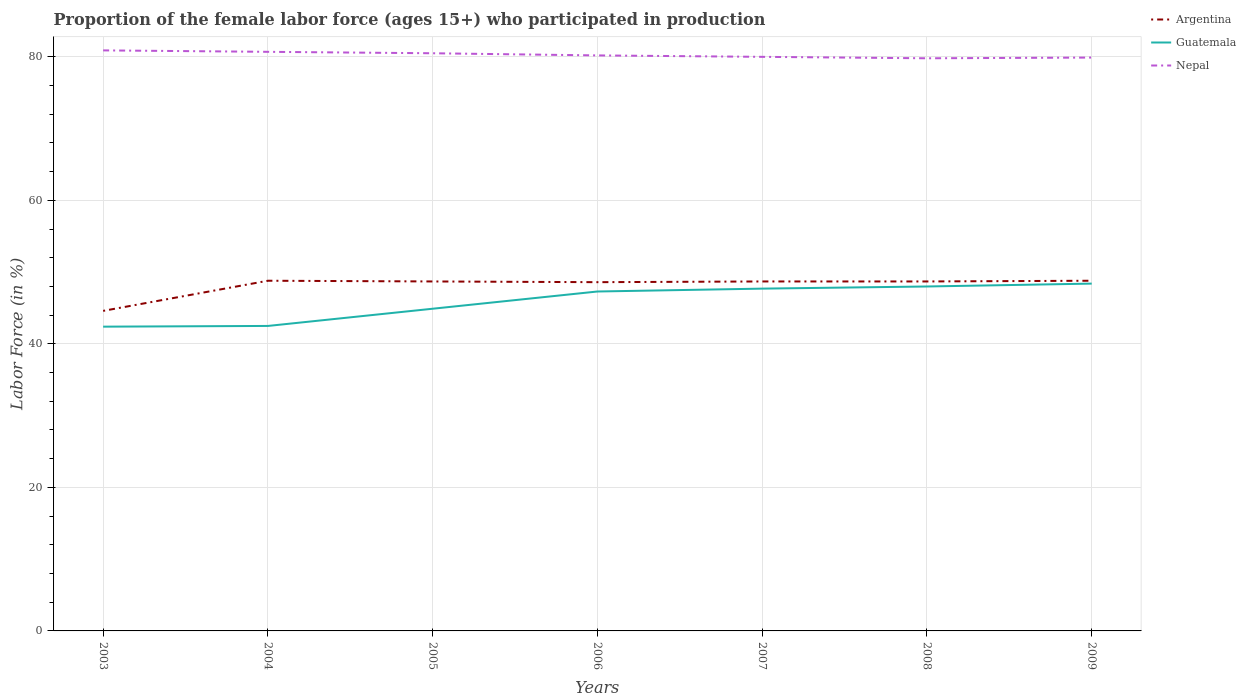Is the number of lines equal to the number of legend labels?
Your response must be concise. Yes. Across all years, what is the maximum proportion of the female labor force who participated in production in Guatemala?
Make the answer very short. 42.4. In which year was the proportion of the female labor force who participated in production in Argentina maximum?
Ensure brevity in your answer.  2003. What is the total proportion of the female labor force who participated in production in Argentina in the graph?
Keep it short and to the point. -0.1. What is the difference between the highest and the second highest proportion of the female labor force who participated in production in Guatemala?
Make the answer very short. 6. What is the difference between the highest and the lowest proportion of the female labor force who participated in production in Guatemala?
Offer a very short reply. 4. How many years are there in the graph?
Provide a succinct answer. 7. Are the values on the major ticks of Y-axis written in scientific E-notation?
Ensure brevity in your answer.  No. What is the title of the graph?
Your response must be concise. Proportion of the female labor force (ages 15+) who participated in production. Does "Switzerland" appear as one of the legend labels in the graph?
Your answer should be very brief. No. What is the label or title of the X-axis?
Make the answer very short. Years. What is the label or title of the Y-axis?
Make the answer very short. Labor Force (in %). What is the Labor Force (in %) in Argentina in 2003?
Make the answer very short. 44.6. What is the Labor Force (in %) in Guatemala in 2003?
Make the answer very short. 42.4. What is the Labor Force (in %) in Nepal in 2003?
Offer a very short reply. 80.9. What is the Labor Force (in %) in Argentina in 2004?
Offer a terse response. 48.8. What is the Labor Force (in %) in Guatemala in 2004?
Keep it short and to the point. 42.5. What is the Labor Force (in %) of Nepal in 2004?
Offer a very short reply. 80.7. What is the Labor Force (in %) in Argentina in 2005?
Provide a short and direct response. 48.7. What is the Labor Force (in %) in Guatemala in 2005?
Keep it short and to the point. 44.9. What is the Labor Force (in %) of Nepal in 2005?
Your answer should be very brief. 80.5. What is the Labor Force (in %) of Argentina in 2006?
Ensure brevity in your answer.  48.6. What is the Labor Force (in %) in Guatemala in 2006?
Give a very brief answer. 47.3. What is the Labor Force (in %) of Nepal in 2006?
Offer a terse response. 80.2. What is the Labor Force (in %) of Argentina in 2007?
Offer a terse response. 48.7. What is the Labor Force (in %) in Guatemala in 2007?
Provide a short and direct response. 47.7. What is the Labor Force (in %) of Nepal in 2007?
Keep it short and to the point. 80. What is the Labor Force (in %) in Argentina in 2008?
Ensure brevity in your answer.  48.7. What is the Labor Force (in %) in Guatemala in 2008?
Keep it short and to the point. 48. What is the Labor Force (in %) of Nepal in 2008?
Offer a very short reply. 79.8. What is the Labor Force (in %) of Argentina in 2009?
Offer a very short reply. 48.8. What is the Labor Force (in %) of Guatemala in 2009?
Your answer should be compact. 48.4. What is the Labor Force (in %) of Nepal in 2009?
Offer a very short reply. 79.9. Across all years, what is the maximum Labor Force (in %) of Argentina?
Make the answer very short. 48.8. Across all years, what is the maximum Labor Force (in %) of Guatemala?
Provide a short and direct response. 48.4. Across all years, what is the maximum Labor Force (in %) of Nepal?
Make the answer very short. 80.9. Across all years, what is the minimum Labor Force (in %) of Argentina?
Keep it short and to the point. 44.6. Across all years, what is the minimum Labor Force (in %) of Guatemala?
Keep it short and to the point. 42.4. Across all years, what is the minimum Labor Force (in %) of Nepal?
Keep it short and to the point. 79.8. What is the total Labor Force (in %) of Argentina in the graph?
Offer a very short reply. 336.9. What is the total Labor Force (in %) of Guatemala in the graph?
Provide a short and direct response. 321.2. What is the total Labor Force (in %) of Nepal in the graph?
Offer a very short reply. 562. What is the difference between the Labor Force (in %) of Guatemala in 2003 and that in 2005?
Ensure brevity in your answer.  -2.5. What is the difference between the Labor Force (in %) in Argentina in 2003 and that in 2006?
Your answer should be compact. -4. What is the difference between the Labor Force (in %) of Guatemala in 2003 and that in 2006?
Offer a very short reply. -4.9. What is the difference between the Labor Force (in %) in Nepal in 2003 and that in 2006?
Give a very brief answer. 0.7. What is the difference between the Labor Force (in %) in Argentina in 2003 and that in 2007?
Your answer should be very brief. -4.1. What is the difference between the Labor Force (in %) of Guatemala in 2003 and that in 2007?
Your response must be concise. -5.3. What is the difference between the Labor Force (in %) of Nepal in 2003 and that in 2007?
Make the answer very short. 0.9. What is the difference between the Labor Force (in %) in Nepal in 2003 and that in 2008?
Offer a terse response. 1.1. What is the difference between the Labor Force (in %) in Argentina in 2003 and that in 2009?
Your answer should be compact. -4.2. What is the difference between the Labor Force (in %) of Argentina in 2004 and that in 2005?
Your answer should be very brief. 0.1. What is the difference between the Labor Force (in %) in Argentina in 2004 and that in 2006?
Make the answer very short. 0.2. What is the difference between the Labor Force (in %) of Argentina in 2004 and that in 2007?
Ensure brevity in your answer.  0.1. What is the difference between the Labor Force (in %) of Guatemala in 2004 and that in 2007?
Provide a succinct answer. -5.2. What is the difference between the Labor Force (in %) of Argentina in 2004 and that in 2008?
Your response must be concise. 0.1. What is the difference between the Labor Force (in %) of Guatemala in 2004 and that in 2009?
Your answer should be very brief. -5.9. What is the difference between the Labor Force (in %) in Nepal in 2004 and that in 2009?
Provide a short and direct response. 0.8. What is the difference between the Labor Force (in %) in Argentina in 2005 and that in 2006?
Your answer should be very brief. 0.1. What is the difference between the Labor Force (in %) in Guatemala in 2005 and that in 2006?
Give a very brief answer. -2.4. What is the difference between the Labor Force (in %) of Nepal in 2005 and that in 2006?
Your answer should be very brief. 0.3. What is the difference between the Labor Force (in %) of Argentina in 2005 and that in 2008?
Offer a very short reply. 0. What is the difference between the Labor Force (in %) of Guatemala in 2005 and that in 2008?
Your response must be concise. -3.1. What is the difference between the Labor Force (in %) of Argentina in 2005 and that in 2009?
Offer a very short reply. -0.1. What is the difference between the Labor Force (in %) of Guatemala in 2005 and that in 2009?
Your answer should be very brief. -3.5. What is the difference between the Labor Force (in %) of Nepal in 2005 and that in 2009?
Provide a succinct answer. 0.6. What is the difference between the Labor Force (in %) in Argentina in 2006 and that in 2007?
Provide a succinct answer. -0.1. What is the difference between the Labor Force (in %) of Guatemala in 2006 and that in 2008?
Offer a terse response. -0.7. What is the difference between the Labor Force (in %) in Argentina in 2006 and that in 2009?
Keep it short and to the point. -0.2. What is the difference between the Labor Force (in %) in Argentina in 2007 and that in 2008?
Offer a terse response. 0. What is the difference between the Labor Force (in %) in Guatemala in 2007 and that in 2008?
Give a very brief answer. -0.3. What is the difference between the Labor Force (in %) in Guatemala in 2007 and that in 2009?
Offer a terse response. -0.7. What is the difference between the Labor Force (in %) of Argentina in 2008 and that in 2009?
Ensure brevity in your answer.  -0.1. What is the difference between the Labor Force (in %) in Nepal in 2008 and that in 2009?
Provide a succinct answer. -0.1. What is the difference between the Labor Force (in %) in Argentina in 2003 and the Labor Force (in %) in Guatemala in 2004?
Offer a very short reply. 2.1. What is the difference between the Labor Force (in %) of Argentina in 2003 and the Labor Force (in %) of Nepal in 2004?
Provide a succinct answer. -36.1. What is the difference between the Labor Force (in %) in Guatemala in 2003 and the Labor Force (in %) in Nepal in 2004?
Keep it short and to the point. -38.3. What is the difference between the Labor Force (in %) in Argentina in 2003 and the Labor Force (in %) in Nepal in 2005?
Ensure brevity in your answer.  -35.9. What is the difference between the Labor Force (in %) of Guatemala in 2003 and the Labor Force (in %) of Nepal in 2005?
Make the answer very short. -38.1. What is the difference between the Labor Force (in %) of Argentina in 2003 and the Labor Force (in %) of Guatemala in 2006?
Offer a very short reply. -2.7. What is the difference between the Labor Force (in %) of Argentina in 2003 and the Labor Force (in %) of Nepal in 2006?
Provide a short and direct response. -35.6. What is the difference between the Labor Force (in %) of Guatemala in 2003 and the Labor Force (in %) of Nepal in 2006?
Give a very brief answer. -37.8. What is the difference between the Labor Force (in %) in Argentina in 2003 and the Labor Force (in %) in Guatemala in 2007?
Give a very brief answer. -3.1. What is the difference between the Labor Force (in %) in Argentina in 2003 and the Labor Force (in %) in Nepal in 2007?
Make the answer very short. -35.4. What is the difference between the Labor Force (in %) in Guatemala in 2003 and the Labor Force (in %) in Nepal in 2007?
Offer a very short reply. -37.6. What is the difference between the Labor Force (in %) of Argentina in 2003 and the Labor Force (in %) of Guatemala in 2008?
Provide a succinct answer. -3.4. What is the difference between the Labor Force (in %) in Argentina in 2003 and the Labor Force (in %) in Nepal in 2008?
Offer a terse response. -35.2. What is the difference between the Labor Force (in %) in Guatemala in 2003 and the Labor Force (in %) in Nepal in 2008?
Your response must be concise. -37.4. What is the difference between the Labor Force (in %) in Argentina in 2003 and the Labor Force (in %) in Nepal in 2009?
Provide a short and direct response. -35.3. What is the difference between the Labor Force (in %) of Guatemala in 2003 and the Labor Force (in %) of Nepal in 2009?
Ensure brevity in your answer.  -37.5. What is the difference between the Labor Force (in %) of Argentina in 2004 and the Labor Force (in %) of Nepal in 2005?
Provide a succinct answer. -31.7. What is the difference between the Labor Force (in %) of Guatemala in 2004 and the Labor Force (in %) of Nepal in 2005?
Offer a terse response. -38. What is the difference between the Labor Force (in %) of Argentina in 2004 and the Labor Force (in %) of Nepal in 2006?
Offer a very short reply. -31.4. What is the difference between the Labor Force (in %) in Guatemala in 2004 and the Labor Force (in %) in Nepal in 2006?
Give a very brief answer. -37.7. What is the difference between the Labor Force (in %) in Argentina in 2004 and the Labor Force (in %) in Nepal in 2007?
Offer a very short reply. -31.2. What is the difference between the Labor Force (in %) of Guatemala in 2004 and the Labor Force (in %) of Nepal in 2007?
Give a very brief answer. -37.5. What is the difference between the Labor Force (in %) in Argentina in 2004 and the Labor Force (in %) in Guatemala in 2008?
Give a very brief answer. 0.8. What is the difference between the Labor Force (in %) in Argentina in 2004 and the Labor Force (in %) in Nepal in 2008?
Provide a succinct answer. -31. What is the difference between the Labor Force (in %) of Guatemala in 2004 and the Labor Force (in %) of Nepal in 2008?
Give a very brief answer. -37.3. What is the difference between the Labor Force (in %) in Argentina in 2004 and the Labor Force (in %) in Nepal in 2009?
Keep it short and to the point. -31.1. What is the difference between the Labor Force (in %) of Guatemala in 2004 and the Labor Force (in %) of Nepal in 2009?
Your answer should be compact. -37.4. What is the difference between the Labor Force (in %) of Argentina in 2005 and the Labor Force (in %) of Guatemala in 2006?
Your response must be concise. 1.4. What is the difference between the Labor Force (in %) of Argentina in 2005 and the Labor Force (in %) of Nepal in 2006?
Your answer should be very brief. -31.5. What is the difference between the Labor Force (in %) of Guatemala in 2005 and the Labor Force (in %) of Nepal in 2006?
Give a very brief answer. -35.3. What is the difference between the Labor Force (in %) of Argentina in 2005 and the Labor Force (in %) of Guatemala in 2007?
Offer a very short reply. 1. What is the difference between the Labor Force (in %) in Argentina in 2005 and the Labor Force (in %) in Nepal in 2007?
Offer a terse response. -31.3. What is the difference between the Labor Force (in %) in Guatemala in 2005 and the Labor Force (in %) in Nepal in 2007?
Offer a very short reply. -35.1. What is the difference between the Labor Force (in %) in Argentina in 2005 and the Labor Force (in %) in Nepal in 2008?
Provide a succinct answer. -31.1. What is the difference between the Labor Force (in %) of Guatemala in 2005 and the Labor Force (in %) of Nepal in 2008?
Provide a short and direct response. -34.9. What is the difference between the Labor Force (in %) of Argentina in 2005 and the Labor Force (in %) of Guatemala in 2009?
Make the answer very short. 0.3. What is the difference between the Labor Force (in %) of Argentina in 2005 and the Labor Force (in %) of Nepal in 2009?
Your response must be concise. -31.2. What is the difference between the Labor Force (in %) of Guatemala in 2005 and the Labor Force (in %) of Nepal in 2009?
Ensure brevity in your answer.  -35. What is the difference between the Labor Force (in %) in Argentina in 2006 and the Labor Force (in %) in Nepal in 2007?
Offer a very short reply. -31.4. What is the difference between the Labor Force (in %) of Guatemala in 2006 and the Labor Force (in %) of Nepal in 2007?
Give a very brief answer. -32.7. What is the difference between the Labor Force (in %) in Argentina in 2006 and the Labor Force (in %) in Guatemala in 2008?
Your response must be concise. 0.6. What is the difference between the Labor Force (in %) in Argentina in 2006 and the Labor Force (in %) in Nepal in 2008?
Your answer should be compact. -31.2. What is the difference between the Labor Force (in %) of Guatemala in 2006 and the Labor Force (in %) of Nepal in 2008?
Your response must be concise. -32.5. What is the difference between the Labor Force (in %) of Argentina in 2006 and the Labor Force (in %) of Nepal in 2009?
Offer a terse response. -31.3. What is the difference between the Labor Force (in %) of Guatemala in 2006 and the Labor Force (in %) of Nepal in 2009?
Offer a terse response. -32.6. What is the difference between the Labor Force (in %) in Argentina in 2007 and the Labor Force (in %) in Guatemala in 2008?
Offer a very short reply. 0.7. What is the difference between the Labor Force (in %) of Argentina in 2007 and the Labor Force (in %) of Nepal in 2008?
Offer a terse response. -31.1. What is the difference between the Labor Force (in %) in Guatemala in 2007 and the Labor Force (in %) in Nepal in 2008?
Offer a terse response. -32.1. What is the difference between the Labor Force (in %) of Argentina in 2007 and the Labor Force (in %) of Guatemala in 2009?
Make the answer very short. 0.3. What is the difference between the Labor Force (in %) in Argentina in 2007 and the Labor Force (in %) in Nepal in 2009?
Keep it short and to the point. -31.2. What is the difference between the Labor Force (in %) of Guatemala in 2007 and the Labor Force (in %) of Nepal in 2009?
Your answer should be compact. -32.2. What is the difference between the Labor Force (in %) of Argentina in 2008 and the Labor Force (in %) of Nepal in 2009?
Provide a succinct answer. -31.2. What is the difference between the Labor Force (in %) of Guatemala in 2008 and the Labor Force (in %) of Nepal in 2009?
Offer a terse response. -31.9. What is the average Labor Force (in %) of Argentina per year?
Give a very brief answer. 48.13. What is the average Labor Force (in %) of Guatemala per year?
Offer a terse response. 45.89. What is the average Labor Force (in %) of Nepal per year?
Keep it short and to the point. 80.29. In the year 2003, what is the difference between the Labor Force (in %) in Argentina and Labor Force (in %) in Guatemala?
Your answer should be very brief. 2.2. In the year 2003, what is the difference between the Labor Force (in %) of Argentina and Labor Force (in %) of Nepal?
Keep it short and to the point. -36.3. In the year 2003, what is the difference between the Labor Force (in %) of Guatemala and Labor Force (in %) of Nepal?
Offer a terse response. -38.5. In the year 2004, what is the difference between the Labor Force (in %) in Argentina and Labor Force (in %) in Guatemala?
Provide a short and direct response. 6.3. In the year 2004, what is the difference between the Labor Force (in %) in Argentina and Labor Force (in %) in Nepal?
Give a very brief answer. -31.9. In the year 2004, what is the difference between the Labor Force (in %) of Guatemala and Labor Force (in %) of Nepal?
Offer a very short reply. -38.2. In the year 2005, what is the difference between the Labor Force (in %) of Argentina and Labor Force (in %) of Nepal?
Ensure brevity in your answer.  -31.8. In the year 2005, what is the difference between the Labor Force (in %) of Guatemala and Labor Force (in %) of Nepal?
Offer a terse response. -35.6. In the year 2006, what is the difference between the Labor Force (in %) in Argentina and Labor Force (in %) in Nepal?
Ensure brevity in your answer.  -31.6. In the year 2006, what is the difference between the Labor Force (in %) in Guatemala and Labor Force (in %) in Nepal?
Offer a terse response. -32.9. In the year 2007, what is the difference between the Labor Force (in %) of Argentina and Labor Force (in %) of Nepal?
Ensure brevity in your answer.  -31.3. In the year 2007, what is the difference between the Labor Force (in %) of Guatemala and Labor Force (in %) of Nepal?
Your answer should be compact. -32.3. In the year 2008, what is the difference between the Labor Force (in %) in Argentina and Labor Force (in %) in Guatemala?
Provide a short and direct response. 0.7. In the year 2008, what is the difference between the Labor Force (in %) in Argentina and Labor Force (in %) in Nepal?
Provide a succinct answer. -31.1. In the year 2008, what is the difference between the Labor Force (in %) in Guatemala and Labor Force (in %) in Nepal?
Give a very brief answer. -31.8. In the year 2009, what is the difference between the Labor Force (in %) of Argentina and Labor Force (in %) of Guatemala?
Give a very brief answer. 0.4. In the year 2009, what is the difference between the Labor Force (in %) of Argentina and Labor Force (in %) of Nepal?
Offer a terse response. -31.1. In the year 2009, what is the difference between the Labor Force (in %) of Guatemala and Labor Force (in %) of Nepal?
Ensure brevity in your answer.  -31.5. What is the ratio of the Labor Force (in %) in Argentina in 2003 to that in 2004?
Provide a short and direct response. 0.91. What is the ratio of the Labor Force (in %) in Guatemala in 2003 to that in 2004?
Make the answer very short. 1. What is the ratio of the Labor Force (in %) in Argentina in 2003 to that in 2005?
Your response must be concise. 0.92. What is the ratio of the Labor Force (in %) of Guatemala in 2003 to that in 2005?
Make the answer very short. 0.94. What is the ratio of the Labor Force (in %) of Nepal in 2003 to that in 2005?
Offer a terse response. 1. What is the ratio of the Labor Force (in %) of Argentina in 2003 to that in 2006?
Ensure brevity in your answer.  0.92. What is the ratio of the Labor Force (in %) of Guatemala in 2003 to that in 2006?
Make the answer very short. 0.9. What is the ratio of the Labor Force (in %) of Nepal in 2003 to that in 2006?
Your answer should be compact. 1.01. What is the ratio of the Labor Force (in %) of Argentina in 2003 to that in 2007?
Your response must be concise. 0.92. What is the ratio of the Labor Force (in %) in Guatemala in 2003 to that in 2007?
Provide a succinct answer. 0.89. What is the ratio of the Labor Force (in %) in Nepal in 2003 to that in 2007?
Provide a succinct answer. 1.01. What is the ratio of the Labor Force (in %) in Argentina in 2003 to that in 2008?
Ensure brevity in your answer.  0.92. What is the ratio of the Labor Force (in %) of Guatemala in 2003 to that in 2008?
Make the answer very short. 0.88. What is the ratio of the Labor Force (in %) of Nepal in 2003 to that in 2008?
Provide a succinct answer. 1.01. What is the ratio of the Labor Force (in %) in Argentina in 2003 to that in 2009?
Provide a succinct answer. 0.91. What is the ratio of the Labor Force (in %) in Guatemala in 2003 to that in 2009?
Offer a very short reply. 0.88. What is the ratio of the Labor Force (in %) in Nepal in 2003 to that in 2009?
Give a very brief answer. 1.01. What is the ratio of the Labor Force (in %) in Argentina in 2004 to that in 2005?
Your answer should be compact. 1. What is the ratio of the Labor Force (in %) in Guatemala in 2004 to that in 2005?
Your answer should be very brief. 0.95. What is the ratio of the Labor Force (in %) of Nepal in 2004 to that in 2005?
Your answer should be compact. 1. What is the ratio of the Labor Force (in %) in Guatemala in 2004 to that in 2006?
Provide a succinct answer. 0.9. What is the ratio of the Labor Force (in %) in Nepal in 2004 to that in 2006?
Offer a terse response. 1.01. What is the ratio of the Labor Force (in %) in Argentina in 2004 to that in 2007?
Keep it short and to the point. 1. What is the ratio of the Labor Force (in %) of Guatemala in 2004 to that in 2007?
Keep it short and to the point. 0.89. What is the ratio of the Labor Force (in %) of Nepal in 2004 to that in 2007?
Your response must be concise. 1.01. What is the ratio of the Labor Force (in %) in Guatemala in 2004 to that in 2008?
Make the answer very short. 0.89. What is the ratio of the Labor Force (in %) in Nepal in 2004 to that in 2008?
Keep it short and to the point. 1.01. What is the ratio of the Labor Force (in %) of Argentina in 2004 to that in 2009?
Your answer should be very brief. 1. What is the ratio of the Labor Force (in %) of Guatemala in 2004 to that in 2009?
Provide a succinct answer. 0.88. What is the ratio of the Labor Force (in %) in Guatemala in 2005 to that in 2006?
Your answer should be very brief. 0.95. What is the ratio of the Labor Force (in %) of Argentina in 2005 to that in 2007?
Keep it short and to the point. 1. What is the ratio of the Labor Force (in %) in Guatemala in 2005 to that in 2007?
Provide a succinct answer. 0.94. What is the ratio of the Labor Force (in %) of Nepal in 2005 to that in 2007?
Provide a succinct answer. 1.01. What is the ratio of the Labor Force (in %) of Guatemala in 2005 to that in 2008?
Offer a terse response. 0.94. What is the ratio of the Labor Force (in %) of Nepal in 2005 to that in 2008?
Ensure brevity in your answer.  1.01. What is the ratio of the Labor Force (in %) of Guatemala in 2005 to that in 2009?
Offer a terse response. 0.93. What is the ratio of the Labor Force (in %) of Nepal in 2005 to that in 2009?
Your answer should be very brief. 1.01. What is the ratio of the Labor Force (in %) in Guatemala in 2006 to that in 2008?
Give a very brief answer. 0.99. What is the ratio of the Labor Force (in %) of Guatemala in 2006 to that in 2009?
Provide a succinct answer. 0.98. What is the ratio of the Labor Force (in %) of Nepal in 2006 to that in 2009?
Your response must be concise. 1. What is the ratio of the Labor Force (in %) of Argentina in 2007 to that in 2008?
Give a very brief answer. 1. What is the ratio of the Labor Force (in %) of Argentina in 2007 to that in 2009?
Offer a terse response. 1. What is the ratio of the Labor Force (in %) in Guatemala in 2007 to that in 2009?
Your response must be concise. 0.99. What is the ratio of the Labor Force (in %) in Nepal in 2007 to that in 2009?
Keep it short and to the point. 1. What is the difference between the highest and the second highest Labor Force (in %) of Argentina?
Your response must be concise. 0. What is the difference between the highest and the second highest Labor Force (in %) of Guatemala?
Make the answer very short. 0.4. What is the difference between the highest and the lowest Labor Force (in %) of Nepal?
Your answer should be compact. 1.1. 